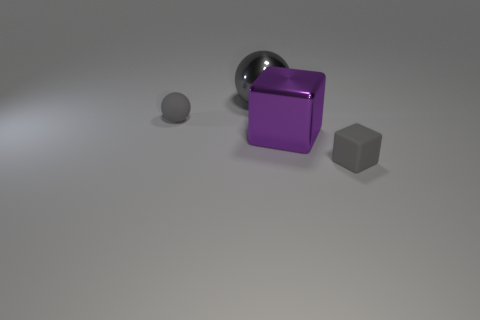What shape is the purple metallic thing?
Provide a succinct answer. Cube. Does the tiny sphere have the same color as the small rubber cube?
Your response must be concise. Yes. There is a shiny ball that is the same size as the purple metal block; what color is it?
Make the answer very short. Gray. What number of purple objects are spheres or matte objects?
Your answer should be compact. 0. Is the number of spheres greater than the number of large brown matte cylinders?
Provide a short and direct response. Yes. There is a rubber cube on the right side of the big purple block; is its size the same as the rubber thing behind the gray cube?
Give a very brief answer. Yes. What is the color of the big shiny object that is behind the gray matte thing that is behind the small cube that is in front of the big ball?
Provide a short and direct response. Gray. Is there a gray matte thing of the same shape as the purple metal object?
Make the answer very short. Yes. Is the number of small gray objects that are behind the metallic cube greater than the number of small rubber balls?
Make the answer very short. No. How many matte things are purple things or blue cylinders?
Provide a short and direct response. 0. 